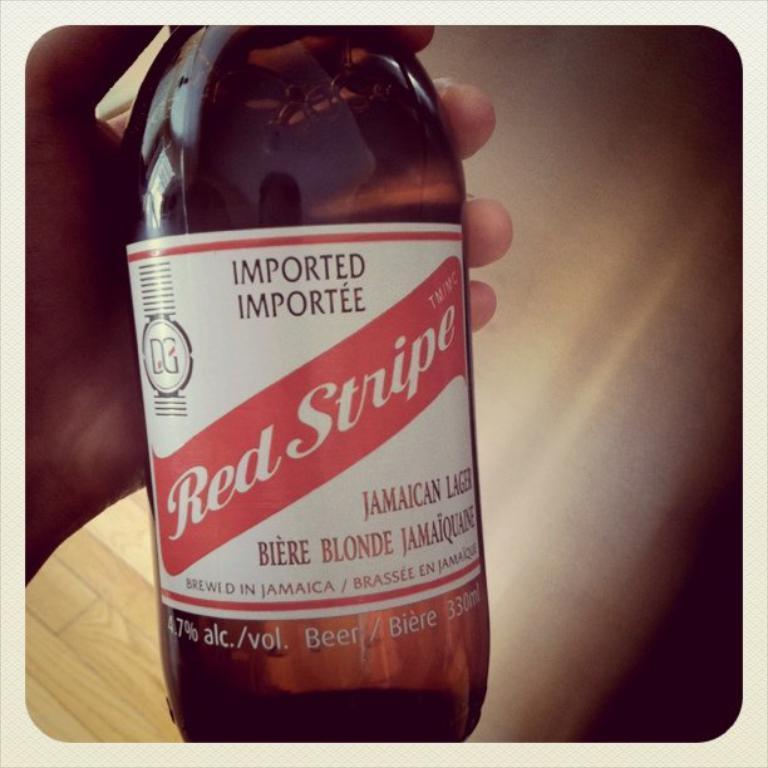Please provide a concise description of this image. In this image I can see a hand of a person is holding a bottle. I can also see something is written over here. 